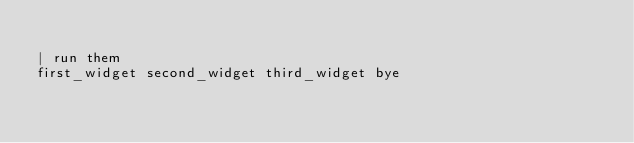Convert code to text. <code><loc_0><loc_0><loc_500><loc_500><_FORTRAN_>
| run them
first_widget second_widget third_widget bye
</code> 